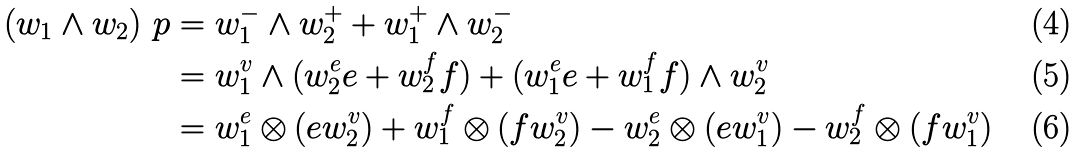<formula> <loc_0><loc_0><loc_500><loc_500>( w _ { 1 } \wedge w _ { 2 } ) _ { \ } p & = w _ { 1 } ^ { - } \wedge w _ { 2 } ^ { + } + w _ { 1 } ^ { + } \wedge w _ { 2 } ^ { - } \\ & = w _ { 1 } ^ { v } \wedge ( w _ { 2 } ^ { e } e + w _ { 2 } ^ { f } f ) + ( w _ { 1 } ^ { e } e + w _ { 1 } ^ { f } f ) \wedge w _ { 2 } ^ { v } \\ & = w _ { 1 } ^ { e } \otimes ( e w _ { 2 } ^ { v } ) + w _ { 1 } ^ { f } \otimes ( f w _ { 2 } ^ { v } ) - w _ { 2 } ^ { e } \otimes ( e w _ { 1 } ^ { v } ) - w _ { 2 } ^ { f } \otimes ( f w _ { 1 } ^ { v } )</formula> 